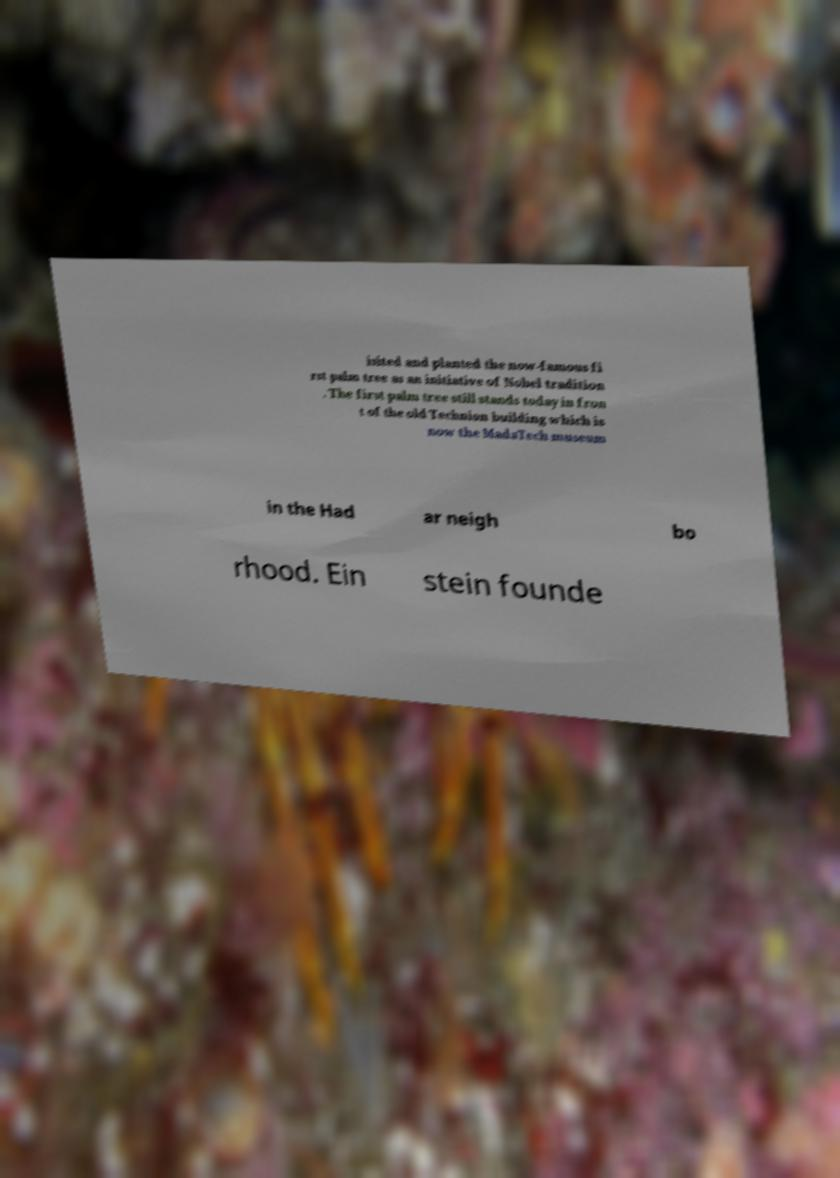What messages or text are displayed in this image? I need them in a readable, typed format. isited and planted the now-famous fi rst palm tree as an initiative of Nobel tradition . The first palm tree still stands today in fron t of the old Technion building which is now the MadaTech museum in the Had ar neigh bo rhood. Ein stein founde 